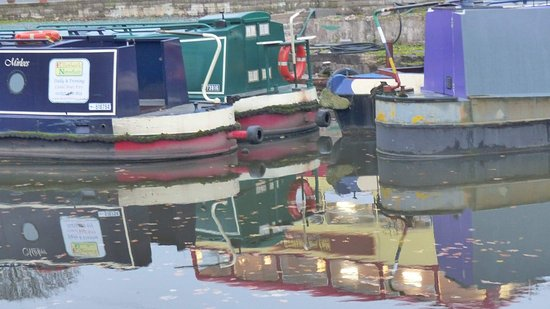How many boats are there in the image? 3 